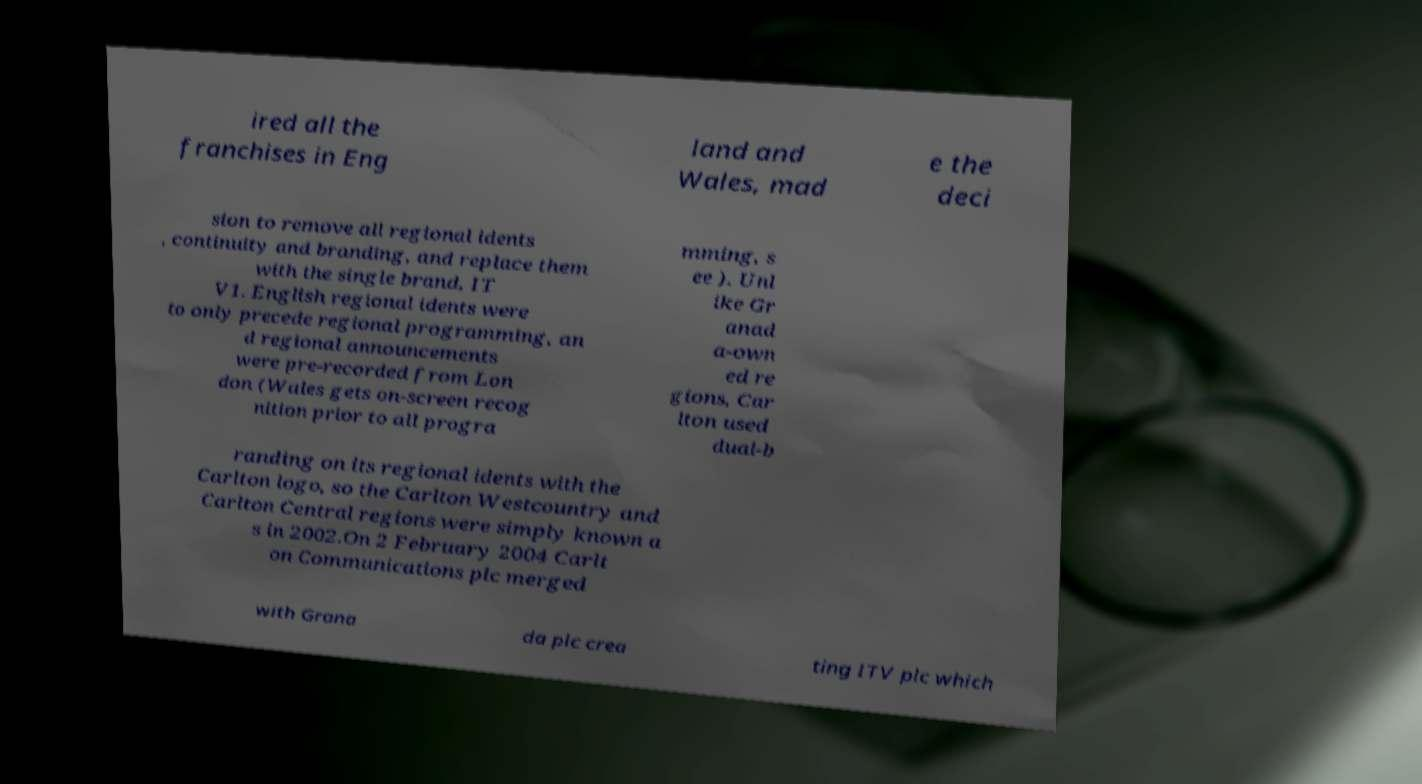What messages or text are displayed in this image? I need them in a readable, typed format. ired all the franchises in Eng land and Wales, mad e the deci sion to remove all regional idents , continuity and branding, and replace them with the single brand, IT V1. English regional idents were to only precede regional programming, an d regional announcements were pre-recorded from Lon don (Wales gets on-screen recog nition prior to all progra mming, s ee ). Unl ike Gr anad a-own ed re gions, Car lton used dual-b randing on its regional idents with the Carlton logo, so the Carlton Westcountry and Carlton Central regions were simply known a s in 2002.On 2 February 2004 Carlt on Communications plc merged with Grana da plc crea ting ITV plc which 